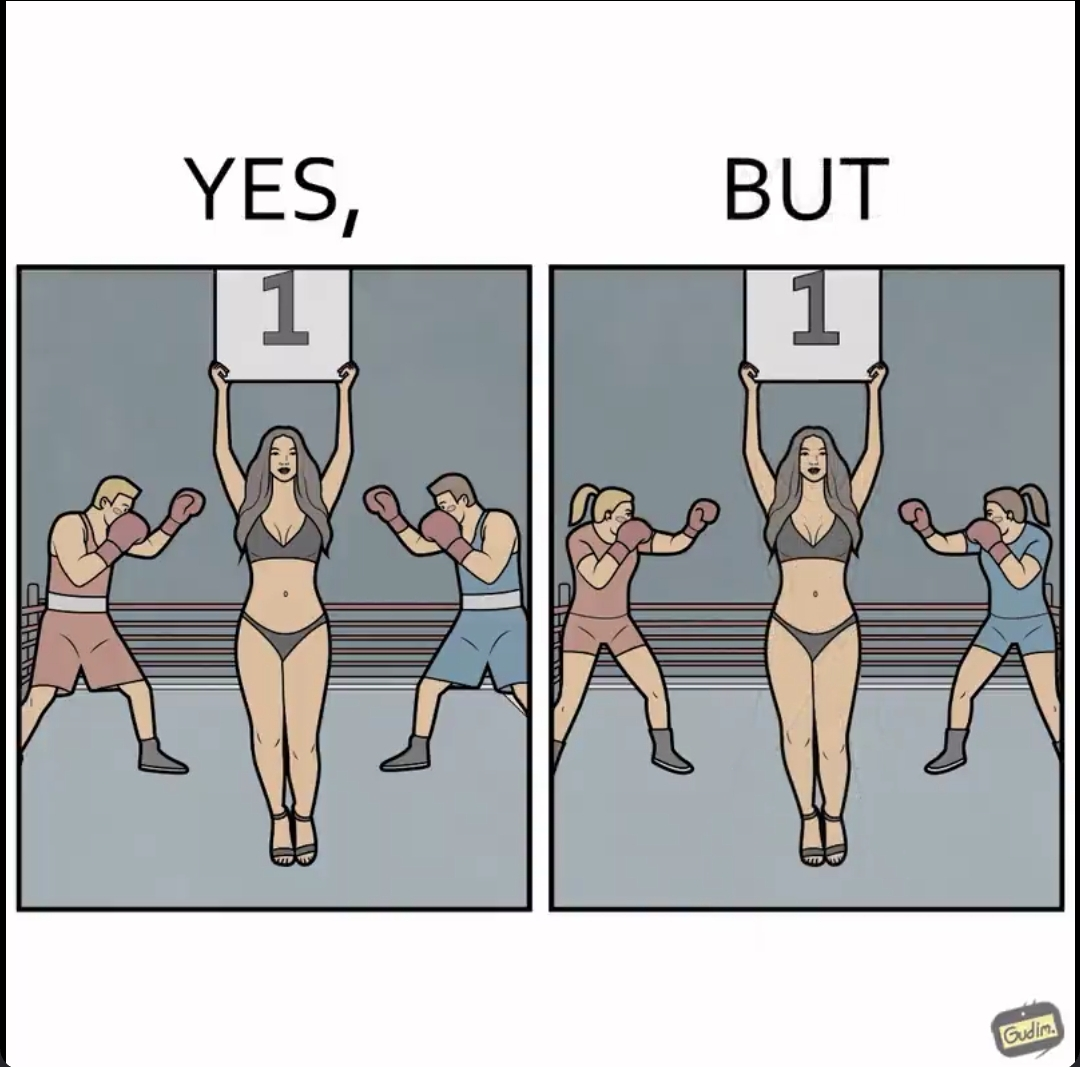Describe what you see in the left and right parts of this image. In the left part of the image: A woman holding a board depicting the round number in a men's boxing match In the right part of the image: A woman holding a board depicting the round number in a women's boxing match 